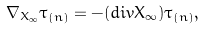Convert formula to latex. <formula><loc_0><loc_0><loc_500><loc_500>\nabla _ { X _ { \infty } } \tau _ { ( n ) } = - ( d i v X _ { \infty } ) \tau _ { ( n ) } ,</formula> 